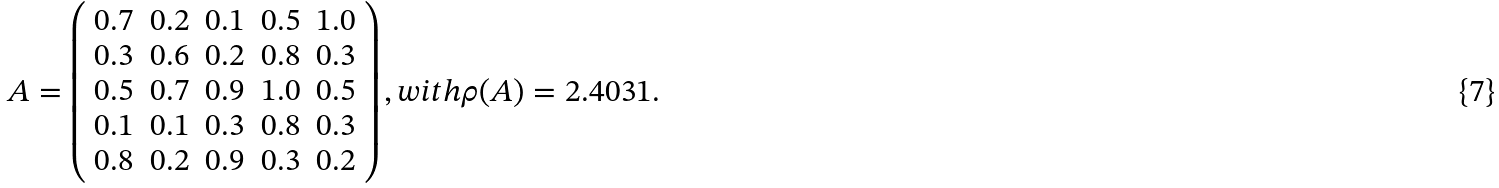<formula> <loc_0><loc_0><loc_500><loc_500>A = \left ( \begin{array} { c c c c c } 0 . 7 & 0 . 2 & 0 . 1 & 0 . 5 & 1 . 0 \\ 0 . 3 & 0 . 6 & 0 . 2 & 0 . 8 & 0 . 3 \\ 0 . 5 & 0 . 7 & 0 . 9 & 1 . 0 & 0 . 5 \\ 0 . 1 & 0 . 1 & 0 . 3 & 0 . 8 & 0 . 3 \\ 0 . 8 & 0 . 2 & 0 . 9 & 0 . 3 & 0 . 2 \end{array} \right ) , w i t h \rho ( A ) = 2 . 4 0 3 1 .</formula> 